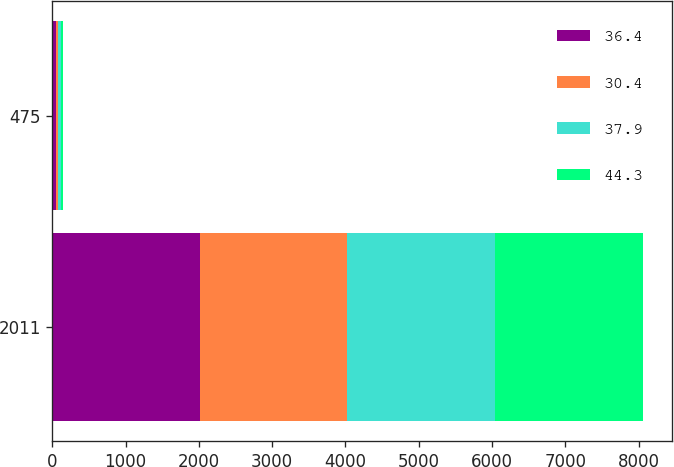Convert chart. <chart><loc_0><loc_0><loc_500><loc_500><stacked_bar_chart><ecel><fcel>2011<fcel>475<nl><fcel>36.4<fcel>2012<fcel>44.3<nl><fcel>30.4<fcel>2013<fcel>37.9<nl><fcel>37.9<fcel>2014<fcel>36.4<nl><fcel>44.3<fcel>2015<fcel>30.4<nl></chart> 